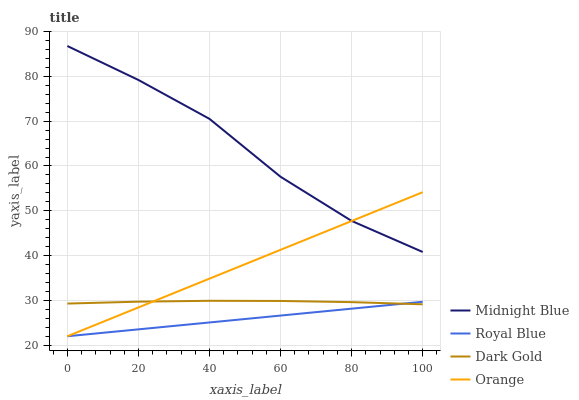Does Royal Blue have the minimum area under the curve?
Answer yes or no. Yes. Does Midnight Blue have the maximum area under the curve?
Answer yes or no. Yes. Does Midnight Blue have the minimum area under the curve?
Answer yes or no. No. Does Royal Blue have the maximum area under the curve?
Answer yes or no. No. Is Royal Blue the smoothest?
Answer yes or no. Yes. Is Midnight Blue the roughest?
Answer yes or no. Yes. Is Midnight Blue the smoothest?
Answer yes or no. No. Is Royal Blue the roughest?
Answer yes or no. No. Does Midnight Blue have the lowest value?
Answer yes or no. No. Does Royal Blue have the highest value?
Answer yes or no. No. Is Dark Gold less than Midnight Blue?
Answer yes or no. Yes. Is Midnight Blue greater than Royal Blue?
Answer yes or no. Yes. Does Dark Gold intersect Midnight Blue?
Answer yes or no. No. 